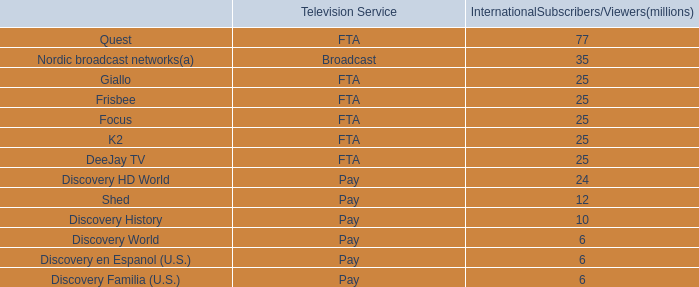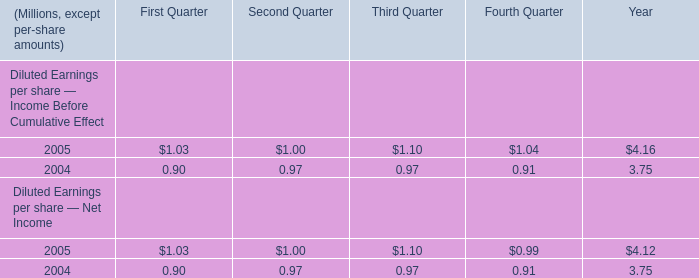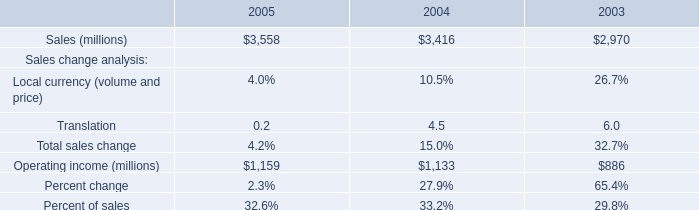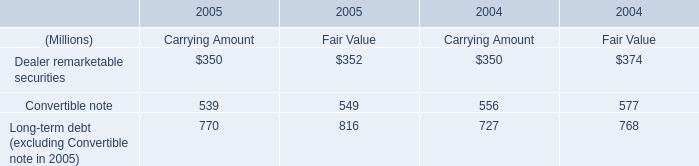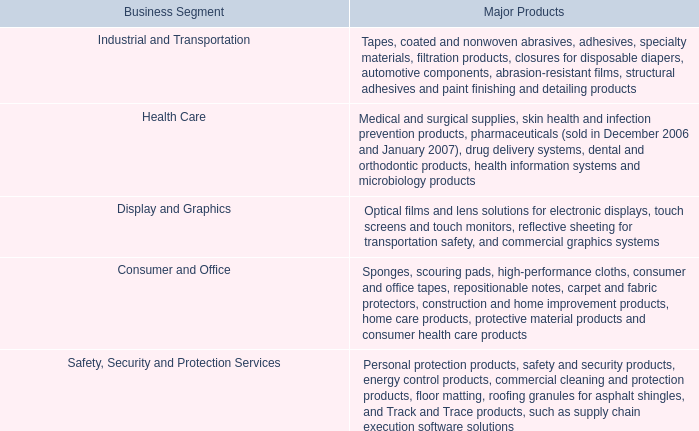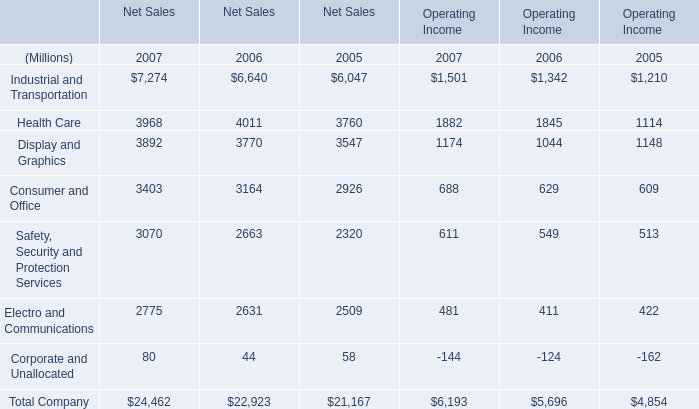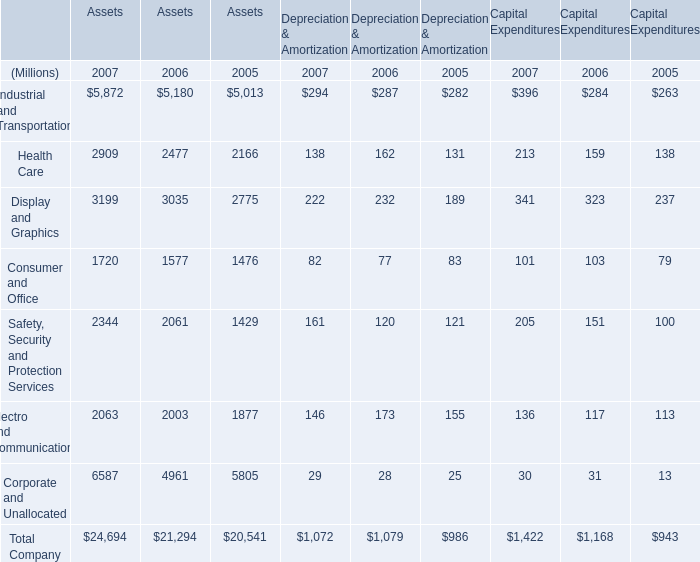What was the total amount of the Industrial and Transportation in the years where Health Care for Assets greater than 2900? (in Million) 
Computations: ((5872 + 294) + 396)
Answer: 6562.0. 